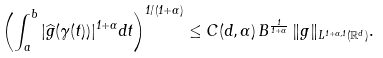Convert formula to latex. <formula><loc_0><loc_0><loc_500><loc_500>\left ( \int _ { a } ^ { b } | \widehat { g } ( \gamma ( t ) ) | ^ { 1 + \alpha } d t \right ) ^ { 1 / ( 1 + \alpha ) } \leq C ( d , \alpha ) \, B ^ { \frac { 1 } { 1 + \alpha } } \, \| g \| _ { L ^ { 1 + \alpha , 1 } ( \mathbb { R } ^ { d } ) } .</formula> 